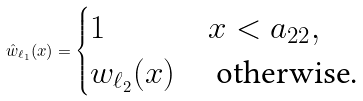<formula> <loc_0><loc_0><loc_500><loc_500>\hat { w } _ { \ell _ { 1 } } ( x ) = \begin{cases} 1 & x < a _ { 2 2 } , \\ w _ { \ell _ { 2 } } ( x ) & \text { otherwise.} \end{cases}</formula> 